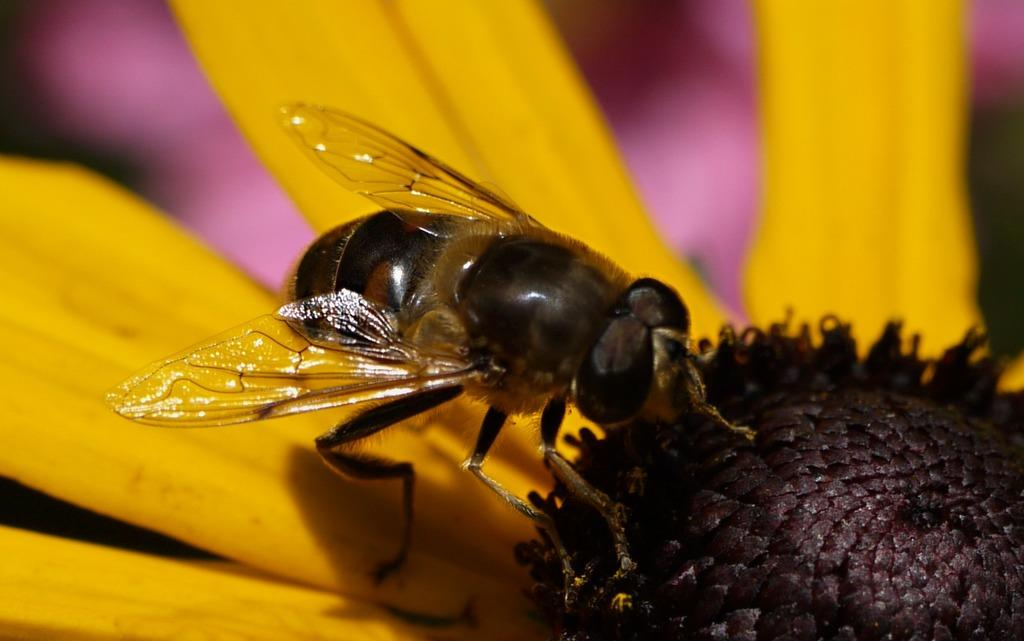What is the main subject of the image? The main subject of the image is a bee. Where is the bee located in the image? The bee is on a flower. Can you describe the flower in the image? The flower has yellow petals. What is the appearance of the background in the image? The background of the image is blurred. What type of rice can be seen in the image? There is no rice present in the image; it features a bee on a yellow flower with a blurred background. 